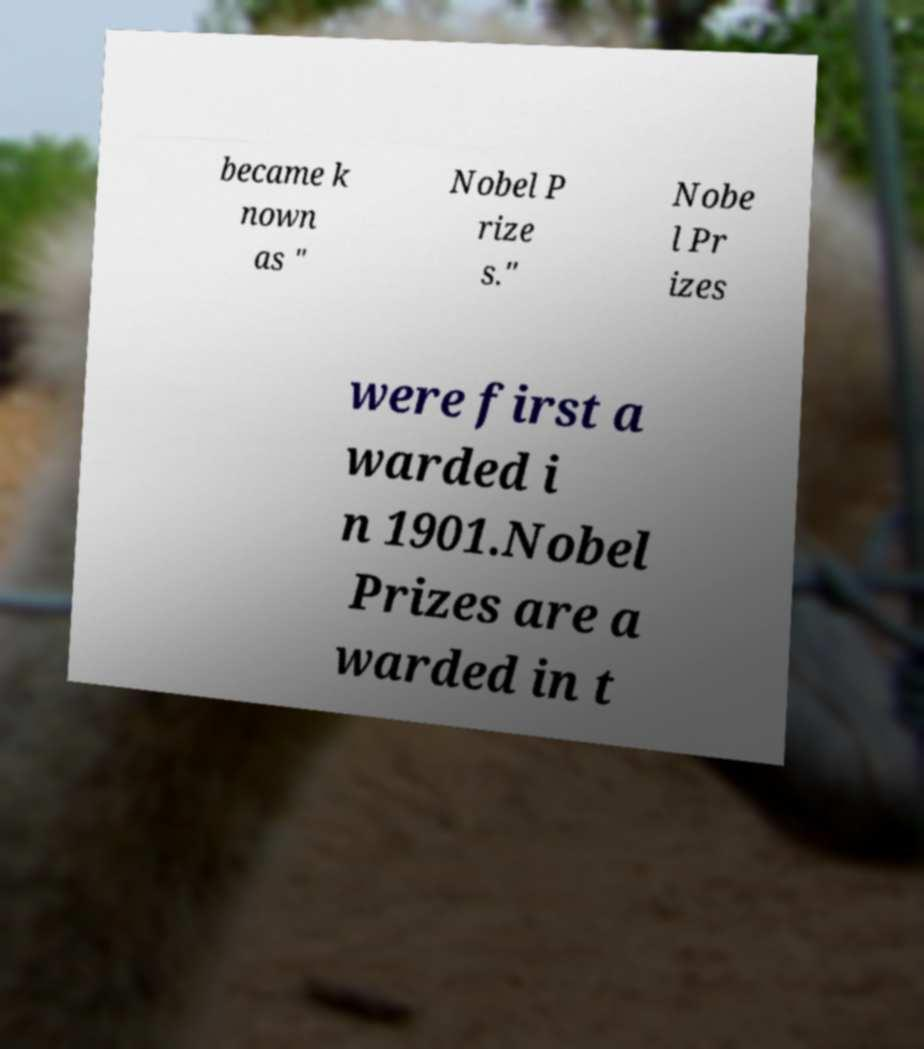I need the written content from this picture converted into text. Can you do that? became k nown as " Nobel P rize s." Nobe l Pr izes were first a warded i n 1901.Nobel Prizes are a warded in t 